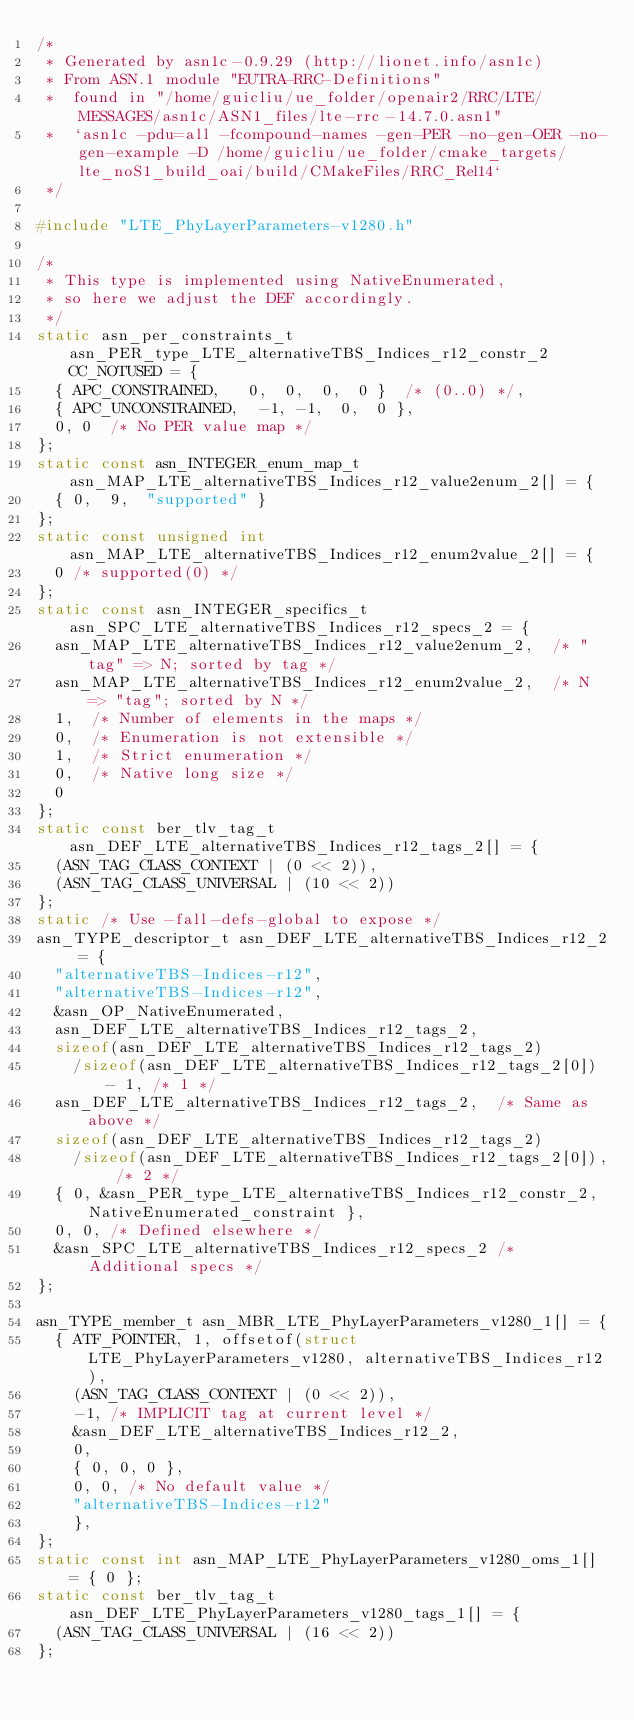Convert code to text. <code><loc_0><loc_0><loc_500><loc_500><_C_>/*
 * Generated by asn1c-0.9.29 (http://lionet.info/asn1c)
 * From ASN.1 module "EUTRA-RRC-Definitions"
 * 	found in "/home/guicliu/ue_folder/openair2/RRC/LTE/MESSAGES/asn1c/ASN1_files/lte-rrc-14.7.0.asn1"
 * 	`asn1c -pdu=all -fcompound-names -gen-PER -no-gen-OER -no-gen-example -D /home/guicliu/ue_folder/cmake_targets/lte_noS1_build_oai/build/CMakeFiles/RRC_Rel14`
 */

#include "LTE_PhyLayerParameters-v1280.h"

/*
 * This type is implemented using NativeEnumerated,
 * so here we adjust the DEF accordingly.
 */
static asn_per_constraints_t asn_PER_type_LTE_alternativeTBS_Indices_r12_constr_2 CC_NOTUSED = {
	{ APC_CONSTRAINED,	 0,  0,  0,  0 }	/* (0..0) */,
	{ APC_UNCONSTRAINED,	-1, -1,  0,  0 },
	0, 0	/* No PER value map */
};
static const asn_INTEGER_enum_map_t asn_MAP_LTE_alternativeTBS_Indices_r12_value2enum_2[] = {
	{ 0,	9,	"supported" }
};
static const unsigned int asn_MAP_LTE_alternativeTBS_Indices_r12_enum2value_2[] = {
	0	/* supported(0) */
};
static const asn_INTEGER_specifics_t asn_SPC_LTE_alternativeTBS_Indices_r12_specs_2 = {
	asn_MAP_LTE_alternativeTBS_Indices_r12_value2enum_2,	/* "tag" => N; sorted by tag */
	asn_MAP_LTE_alternativeTBS_Indices_r12_enum2value_2,	/* N => "tag"; sorted by N */
	1,	/* Number of elements in the maps */
	0,	/* Enumeration is not extensible */
	1,	/* Strict enumeration */
	0,	/* Native long size */
	0
};
static const ber_tlv_tag_t asn_DEF_LTE_alternativeTBS_Indices_r12_tags_2[] = {
	(ASN_TAG_CLASS_CONTEXT | (0 << 2)),
	(ASN_TAG_CLASS_UNIVERSAL | (10 << 2))
};
static /* Use -fall-defs-global to expose */
asn_TYPE_descriptor_t asn_DEF_LTE_alternativeTBS_Indices_r12_2 = {
	"alternativeTBS-Indices-r12",
	"alternativeTBS-Indices-r12",
	&asn_OP_NativeEnumerated,
	asn_DEF_LTE_alternativeTBS_Indices_r12_tags_2,
	sizeof(asn_DEF_LTE_alternativeTBS_Indices_r12_tags_2)
		/sizeof(asn_DEF_LTE_alternativeTBS_Indices_r12_tags_2[0]) - 1, /* 1 */
	asn_DEF_LTE_alternativeTBS_Indices_r12_tags_2,	/* Same as above */
	sizeof(asn_DEF_LTE_alternativeTBS_Indices_r12_tags_2)
		/sizeof(asn_DEF_LTE_alternativeTBS_Indices_r12_tags_2[0]), /* 2 */
	{ 0, &asn_PER_type_LTE_alternativeTBS_Indices_r12_constr_2, NativeEnumerated_constraint },
	0, 0,	/* Defined elsewhere */
	&asn_SPC_LTE_alternativeTBS_Indices_r12_specs_2	/* Additional specs */
};

asn_TYPE_member_t asn_MBR_LTE_PhyLayerParameters_v1280_1[] = {
	{ ATF_POINTER, 1, offsetof(struct LTE_PhyLayerParameters_v1280, alternativeTBS_Indices_r12),
		(ASN_TAG_CLASS_CONTEXT | (0 << 2)),
		-1,	/* IMPLICIT tag at current level */
		&asn_DEF_LTE_alternativeTBS_Indices_r12_2,
		0,
		{ 0, 0, 0 },
		0, 0, /* No default value */
		"alternativeTBS-Indices-r12"
		},
};
static const int asn_MAP_LTE_PhyLayerParameters_v1280_oms_1[] = { 0 };
static const ber_tlv_tag_t asn_DEF_LTE_PhyLayerParameters_v1280_tags_1[] = {
	(ASN_TAG_CLASS_UNIVERSAL | (16 << 2))
};</code> 